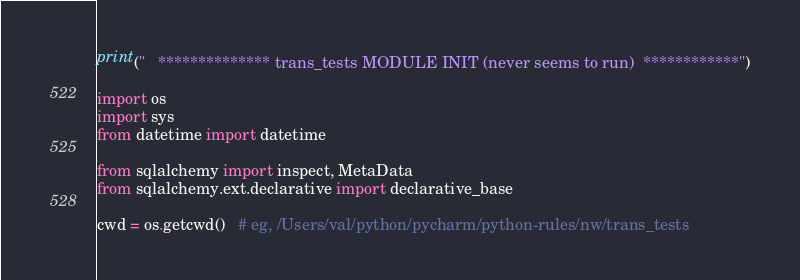<code> <loc_0><loc_0><loc_500><loc_500><_Python_>print("   ************** trans_tests MODULE INIT (never seems to run)  ************")

import os
import sys
from datetime import datetime

from sqlalchemy import inspect, MetaData
from sqlalchemy.ext.declarative import declarative_base

cwd = os.getcwd()   # eg, /Users/val/python/pycharm/python-rules/nw/trans_tests</code> 